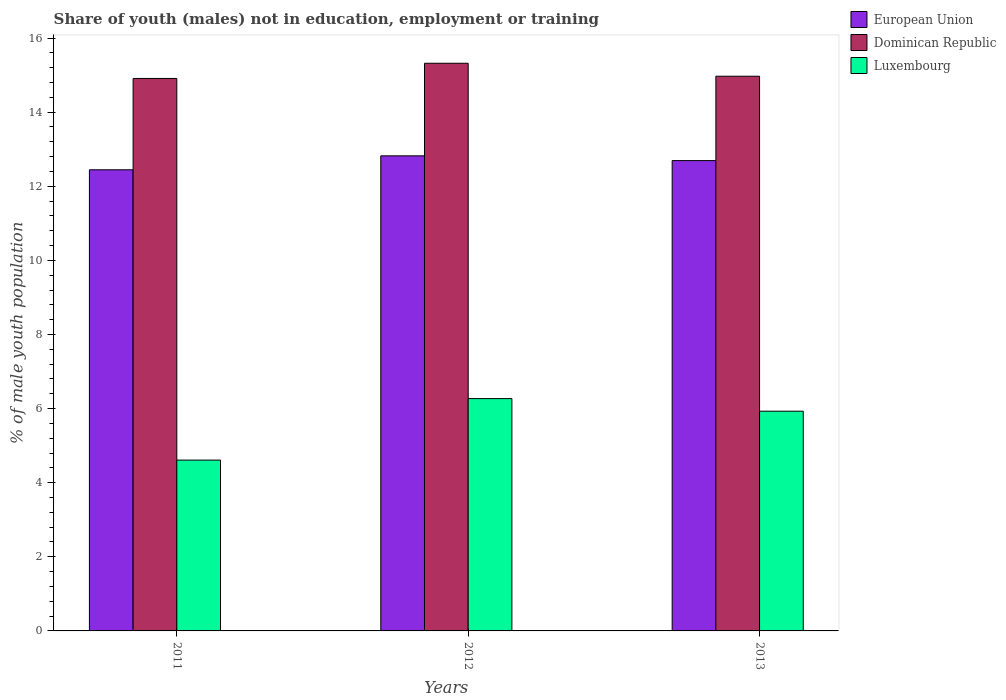How many groups of bars are there?
Offer a terse response. 3. Are the number of bars per tick equal to the number of legend labels?
Provide a short and direct response. Yes. Are the number of bars on each tick of the X-axis equal?
Keep it short and to the point. Yes. How many bars are there on the 1st tick from the right?
Your response must be concise. 3. What is the percentage of unemployed males population in in Luxembourg in 2013?
Provide a short and direct response. 5.93. Across all years, what is the maximum percentage of unemployed males population in in Luxembourg?
Offer a terse response. 6.27. Across all years, what is the minimum percentage of unemployed males population in in Dominican Republic?
Make the answer very short. 14.91. In which year was the percentage of unemployed males population in in European Union maximum?
Your response must be concise. 2012. What is the total percentage of unemployed males population in in Luxembourg in the graph?
Offer a very short reply. 16.81. What is the difference between the percentage of unemployed males population in in Luxembourg in 2011 and that in 2013?
Give a very brief answer. -1.32. What is the difference between the percentage of unemployed males population in in Luxembourg in 2012 and the percentage of unemployed males population in in European Union in 2013?
Your answer should be very brief. -6.42. What is the average percentage of unemployed males population in in Dominican Republic per year?
Your response must be concise. 15.07. In the year 2013, what is the difference between the percentage of unemployed males population in in Dominican Republic and percentage of unemployed males population in in European Union?
Your response must be concise. 2.28. What is the ratio of the percentage of unemployed males population in in European Union in 2012 to that in 2013?
Your answer should be compact. 1.01. Is the percentage of unemployed males population in in Luxembourg in 2012 less than that in 2013?
Offer a terse response. No. Is the difference between the percentage of unemployed males population in in Dominican Republic in 2011 and 2013 greater than the difference between the percentage of unemployed males population in in European Union in 2011 and 2013?
Provide a short and direct response. Yes. What is the difference between the highest and the second highest percentage of unemployed males population in in Dominican Republic?
Keep it short and to the point. 0.35. What is the difference between the highest and the lowest percentage of unemployed males population in in European Union?
Make the answer very short. 0.38. Is the sum of the percentage of unemployed males population in in Luxembourg in 2011 and 2012 greater than the maximum percentage of unemployed males population in in European Union across all years?
Provide a succinct answer. No. What does the 3rd bar from the left in 2013 represents?
Ensure brevity in your answer.  Luxembourg. What does the 1st bar from the right in 2013 represents?
Your response must be concise. Luxembourg. Is it the case that in every year, the sum of the percentage of unemployed males population in in Dominican Republic and percentage of unemployed males population in in European Union is greater than the percentage of unemployed males population in in Luxembourg?
Ensure brevity in your answer.  Yes. How many bars are there?
Your response must be concise. 9. Are all the bars in the graph horizontal?
Offer a very short reply. No. Are the values on the major ticks of Y-axis written in scientific E-notation?
Give a very brief answer. No. Does the graph contain any zero values?
Your answer should be compact. No. Where does the legend appear in the graph?
Provide a short and direct response. Top right. How many legend labels are there?
Your answer should be compact. 3. How are the legend labels stacked?
Ensure brevity in your answer.  Vertical. What is the title of the graph?
Your answer should be compact. Share of youth (males) not in education, employment or training. Does "Macedonia" appear as one of the legend labels in the graph?
Your answer should be very brief. No. What is the label or title of the Y-axis?
Keep it short and to the point. % of male youth population. What is the % of male youth population in European Union in 2011?
Make the answer very short. 12.45. What is the % of male youth population in Dominican Republic in 2011?
Your answer should be compact. 14.91. What is the % of male youth population in Luxembourg in 2011?
Ensure brevity in your answer.  4.61. What is the % of male youth population in European Union in 2012?
Provide a short and direct response. 12.82. What is the % of male youth population in Dominican Republic in 2012?
Provide a succinct answer. 15.32. What is the % of male youth population of Luxembourg in 2012?
Offer a very short reply. 6.27. What is the % of male youth population in European Union in 2013?
Offer a very short reply. 12.69. What is the % of male youth population in Dominican Republic in 2013?
Your response must be concise. 14.97. What is the % of male youth population in Luxembourg in 2013?
Offer a very short reply. 5.93. Across all years, what is the maximum % of male youth population of European Union?
Offer a terse response. 12.82. Across all years, what is the maximum % of male youth population of Dominican Republic?
Offer a very short reply. 15.32. Across all years, what is the maximum % of male youth population of Luxembourg?
Provide a succinct answer. 6.27. Across all years, what is the minimum % of male youth population in European Union?
Give a very brief answer. 12.45. Across all years, what is the minimum % of male youth population of Dominican Republic?
Ensure brevity in your answer.  14.91. Across all years, what is the minimum % of male youth population in Luxembourg?
Your response must be concise. 4.61. What is the total % of male youth population of European Union in the graph?
Ensure brevity in your answer.  37.96. What is the total % of male youth population of Dominican Republic in the graph?
Offer a terse response. 45.2. What is the total % of male youth population of Luxembourg in the graph?
Make the answer very short. 16.81. What is the difference between the % of male youth population in European Union in 2011 and that in 2012?
Provide a short and direct response. -0.38. What is the difference between the % of male youth population in Dominican Republic in 2011 and that in 2012?
Offer a very short reply. -0.41. What is the difference between the % of male youth population of Luxembourg in 2011 and that in 2012?
Keep it short and to the point. -1.66. What is the difference between the % of male youth population in European Union in 2011 and that in 2013?
Make the answer very short. -0.25. What is the difference between the % of male youth population in Dominican Republic in 2011 and that in 2013?
Offer a terse response. -0.06. What is the difference between the % of male youth population of Luxembourg in 2011 and that in 2013?
Offer a very short reply. -1.32. What is the difference between the % of male youth population of European Union in 2012 and that in 2013?
Provide a succinct answer. 0.13. What is the difference between the % of male youth population of Luxembourg in 2012 and that in 2013?
Offer a terse response. 0.34. What is the difference between the % of male youth population in European Union in 2011 and the % of male youth population in Dominican Republic in 2012?
Your answer should be very brief. -2.88. What is the difference between the % of male youth population of European Union in 2011 and the % of male youth population of Luxembourg in 2012?
Your response must be concise. 6.17. What is the difference between the % of male youth population in Dominican Republic in 2011 and the % of male youth population in Luxembourg in 2012?
Provide a short and direct response. 8.64. What is the difference between the % of male youth population of European Union in 2011 and the % of male youth population of Dominican Republic in 2013?
Your answer should be compact. -2.52. What is the difference between the % of male youth population of European Union in 2011 and the % of male youth population of Luxembourg in 2013?
Give a very brief answer. 6.51. What is the difference between the % of male youth population in Dominican Republic in 2011 and the % of male youth population in Luxembourg in 2013?
Provide a succinct answer. 8.98. What is the difference between the % of male youth population of European Union in 2012 and the % of male youth population of Dominican Republic in 2013?
Your answer should be compact. -2.15. What is the difference between the % of male youth population in European Union in 2012 and the % of male youth population in Luxembourg in 2013?
Provide a succinct answer. 6.89. What is the difference between the % of male youth population in Dominican Republic in 2012 and the % of male youth population in Luxembourg in 2013?
Offer a very short reply. 9.39. What is the average % of male youth population of European Union per year?
Provide a short and direct response. 12.65. What is the average % of male youth population of Dominican Republic per year?
Give a very brief answer. 15.07. What is the average % of male youth population of Luxembourg per year?
Offer a very short reply. 5.6. In the year 2011, what is the difference between the % of male youth population in European Union and % of male youth population in Dominican Republic?
Ensure brevity in your answer.  -2.46. In the year 2011, what is the difference between the % of male youth population of European Union and % of male youth population of Luxembourg?
Keep it short and to the point. 7.83. In the year 2012, what is the difference between the % of male youth population of European Union and % of male youth population of Dominican Republic?
Your answer should be compact. -2.5. In the year 2012, what is the difference between the % of male youth population in European Union and % of male youth population in Luxembourg?
Keep it short and to the point. 6.55. In the year 2012, what is the difference between the % of male youth population in Dominican Republic and % of male youth population in Luxembourg?
Your response must be concise. 9.05. In the year 2013, what is the difference between the % of male youth population of European Union and % of male youth population of Dominican Republic?
Offer a terse response. -2.28. In the year 2013, what is the difference between the % of male youth population of European Union and % of male youth population of Luxembourg?
Make the answer very short. 6.76. In the year 2013, what is the difference between the % of male youth population of Dominican Republic and % of male youth population of Luxembourg?
Your answer should be compact. 9.04. What is the ratio of the % of male youth population in European Union in 2011 to that in 2012?
Provide a succinct answer. 0.97. What is the ratio of the % of male youth population of Dominican Republic in 2011 to that in 2012?
Give a very brief answer. 0.97. What is the ratio of the % of male youth population in Luxembourg in 2011 to that in 2012?
Keep it short and to the point. 0.74. What is the ratio of the % of male youth population of European Union in 2011 to that in 2013?
Provide a succinct answer. 0.98. What is the ratio of the % of male youth population in Luxembourg in 2011 to that in 2013?
Offer a terse response. 0.78. What is the ratio of the % of male youth population of Dominican Republic in 2012 to that in 2013?
Your answer should be compact. 1.02. What is the ratio of the % of male youth population of Luxembourg in 2012 to that in 2013?
Provide a short and direct response. 1.06. What is the difference between the highest and the second highest % of male youth population of European Union?
Give a very brief answer. 0.13. What is the difference between the highest and the second highest % of male youth population in Luxembourg?
Give a very brief answer. 0.34. What is the difference between the highest and the lowest % of male youth population of European Union?
Provide a short and direct response. 0.38. What is the difference between the highest and the lowest % of male youth population in Dominican Republic?
Keep it short and to the point. 0.41. What is the difference between the highest and the lowest % of male youth population of Luxembourg?
Keep it short and to the point. 1.66. 